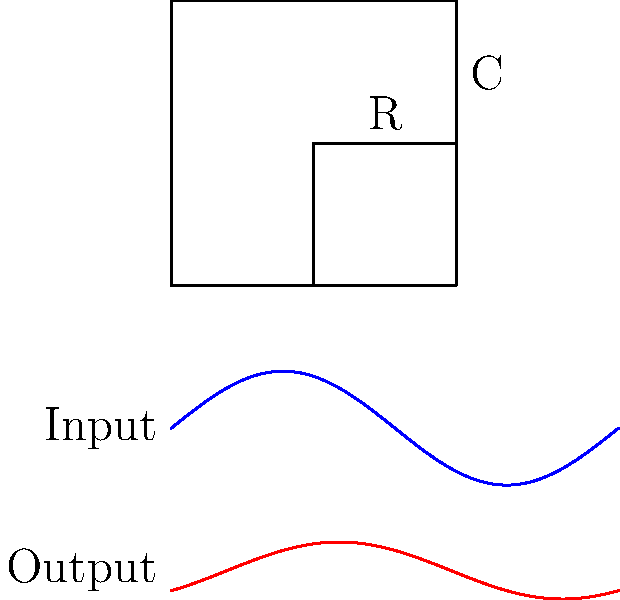In the RC low-pass filter circuit shown above, what is the primary effect on the output signal compared to the input signal? To understand the effect of the RC low-pass filter on the output signal, let's analyze the circuit step-by-step:

1. Circuit composition: The circuit consists of a resistor (R) and a capacitor (C) in series.

2. Low-pass filter behavior:
   a. At low frequencies, the capacitor acts like an open circuit, allowing signals to pass through.
   b. At high frequencies, the capacitor acts like a short circuit, attenuating these signals.

3. Output signal characteristics:
   a. Amplitude: The output signal's amplitude is reduced compared to the input. This is due to the voltage division between R and C.
   b. Phase shift: The output signal is shifted in phase relative to the input. This is caused by the charging and discharging of the capacitor.

4. Frequency response:
   a. Cut-off frequency: $f_c = \frac{1}{2\pi RC}$
   b. Below $f_c$: Signals pass through with minimal attenuation.
   c. Above $f_c$: Signals are progressively attenuated at -20 dB/decade.

5. Time domain analysis:
   a. The capacitor smooths out rapid changes in the input signal.
   b. This results in a more gradual, rounded output waveform.

In the given waveforms:
- The blue curve represents the input signal (a sine wave).
- The red curve represents the output signal, which has:
  1. Reduced amplitude
  2. Phase shift (lagging behind the input)
  3. A more rounded shape

These observations confirm the low-pass filtering effect of the RC circuit.
Answer: Amplitude reduction and phase shift 